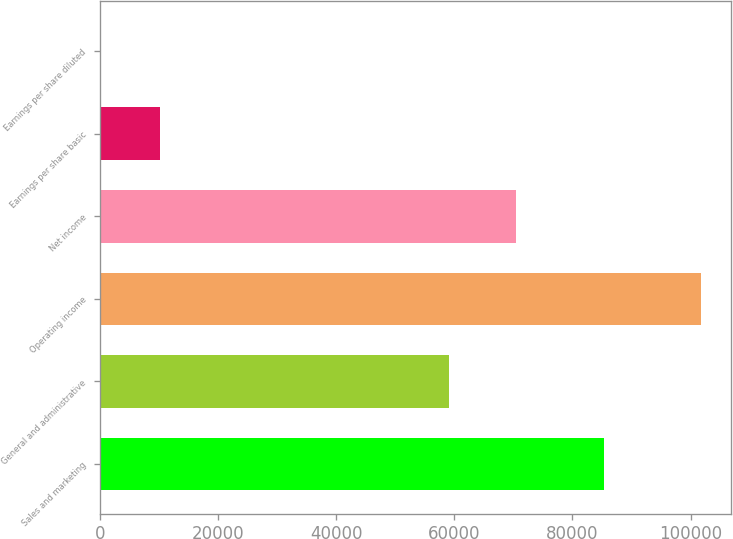<chart> <loc_0><loc_0><loc_500><loc_500><bar_chart><fcel>Sales and marketing<fcel>General and administrative<fcel>Operating income<fcel>Net income<fcel>Earnings per share basic<fcel>Earnings per share diluted<nl><fcel>85361<fcel>59174<fcel>101740<fcel>70421<fcel>10175.1<fcel>1.19<nl></chart> 